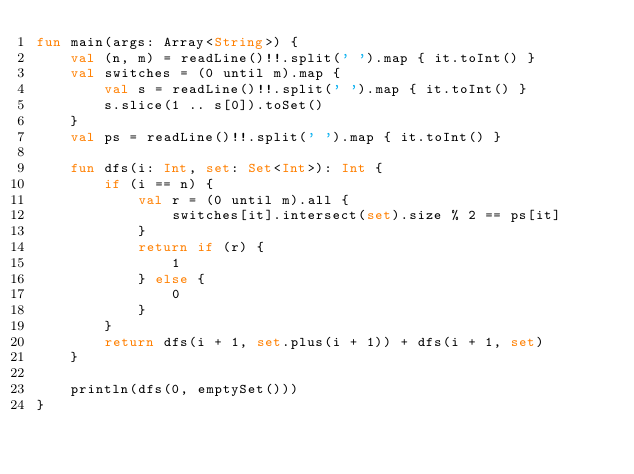Convert code to text. <code><loc_0><loc_0><loc_500><loc_500><_Kotlin_>fun main(args: Array<String>) {
    val (n, m) = readLine()!!.split(' ').map { it.toInt() }
    val switches = (0 until m).map {
        val s = readLine()!!.split(' ').map { it.toInt() }
        s.slice(1 .. s[0]).toSet()
    }
    val ps = readLine()!!.split(' ').map { it.toInt() }

    fun dfs(i: Int, set: Set<Int>): Int {
        if (i == n) {
            val r = (0 until m).all {
                switches[it].intersect(set).size % 2 == ps[it]
            }
            return if (r) {
                1
            } else {
                0
            }
        }
        return dfs(i + 1, set.plus(i + 1)) + dfs(i + 1, set)
    }

    println(dfs(0, emptySet()))
}
</code> 